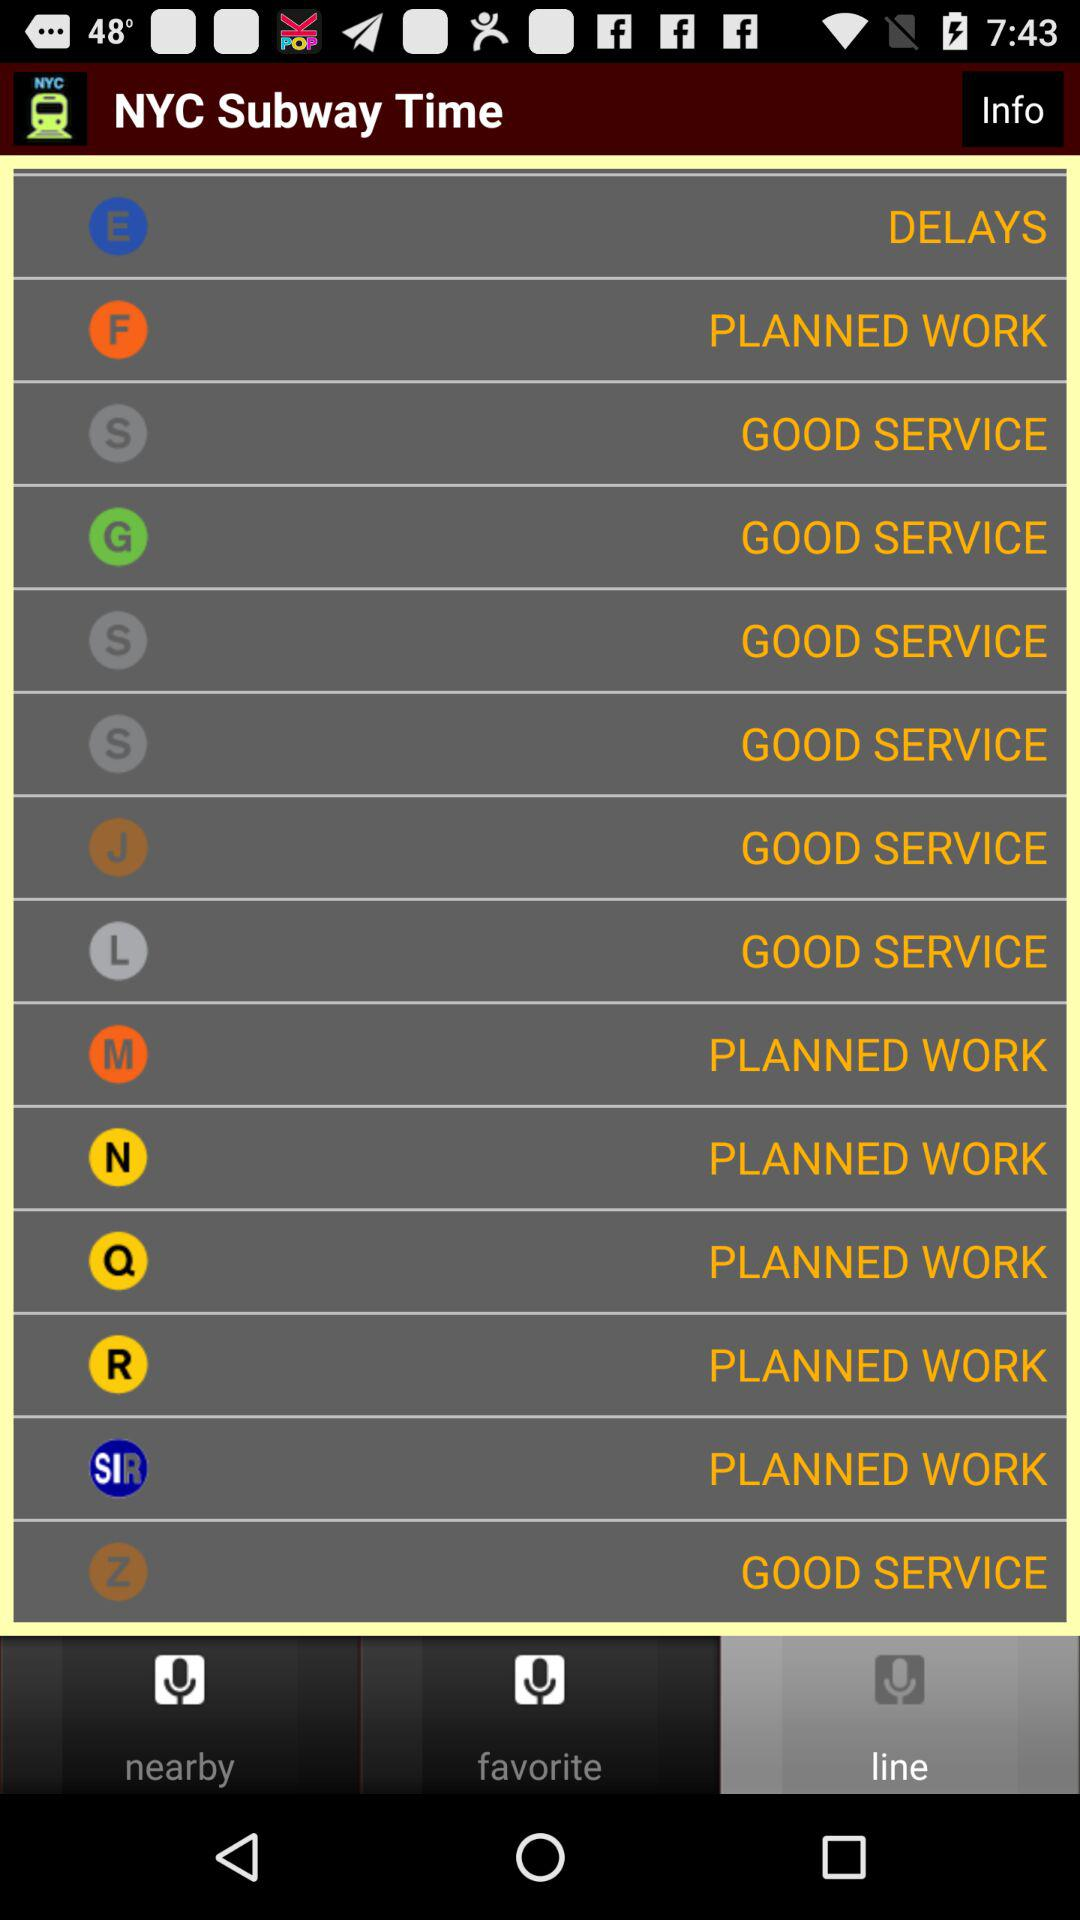How many lines have planned work?
Answer the question using a single word or phrase. 6 